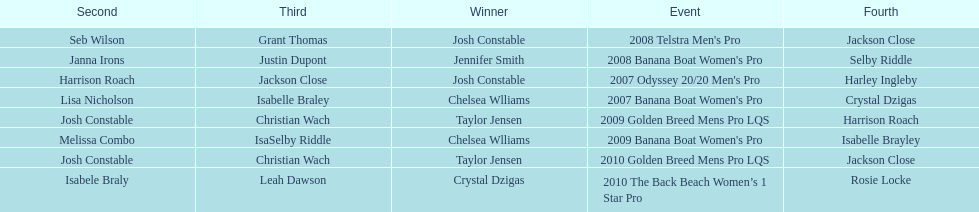At which event did taylor jensen first win? 2009 Golden Breed Mens Pro LQS. 